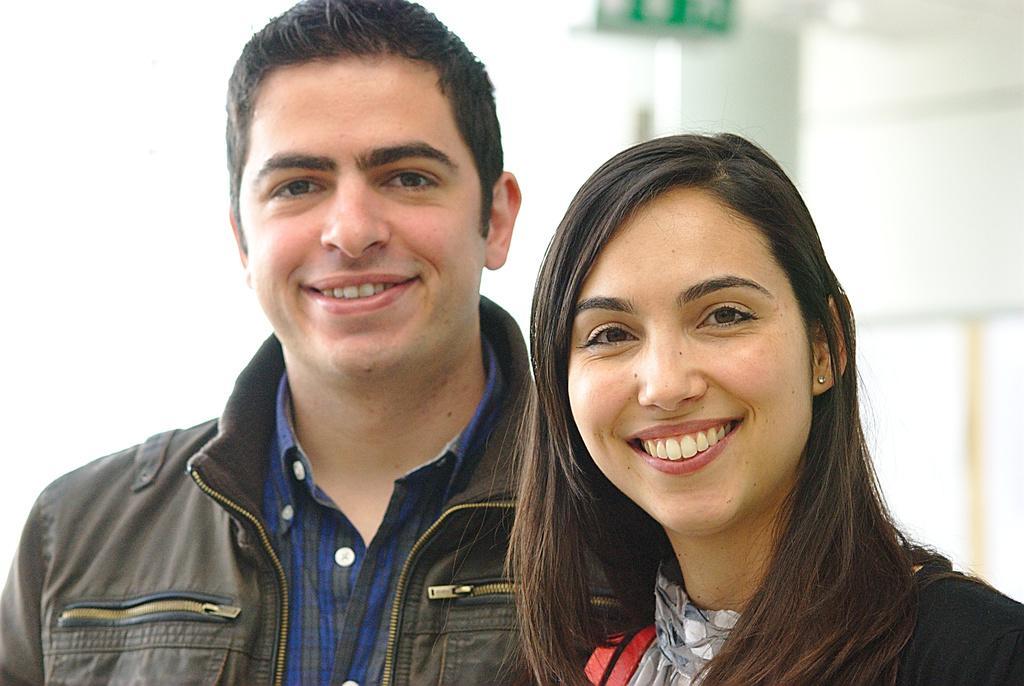How would you summarize this image in a sentence or two? In this image we can see a man and a woman smiling. 